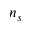<formula> <loc_0><loc_0><loc_500><loc_500>n _ { s }</formula> 